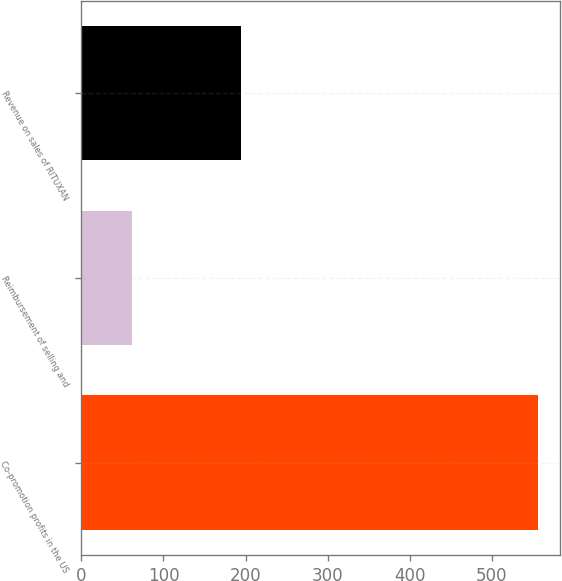Convert chart to OTSL. <chart><loc_0><loc_0><loc_500><loc_500><bar_chart><fcel>Co-promotion profits in the US<fcel>Reimbursement of selling and<fcel>Revenue on sales of RITUXAN<nl><fcel>555.8<fcel>61.1<fcel>194<nl></chart> 